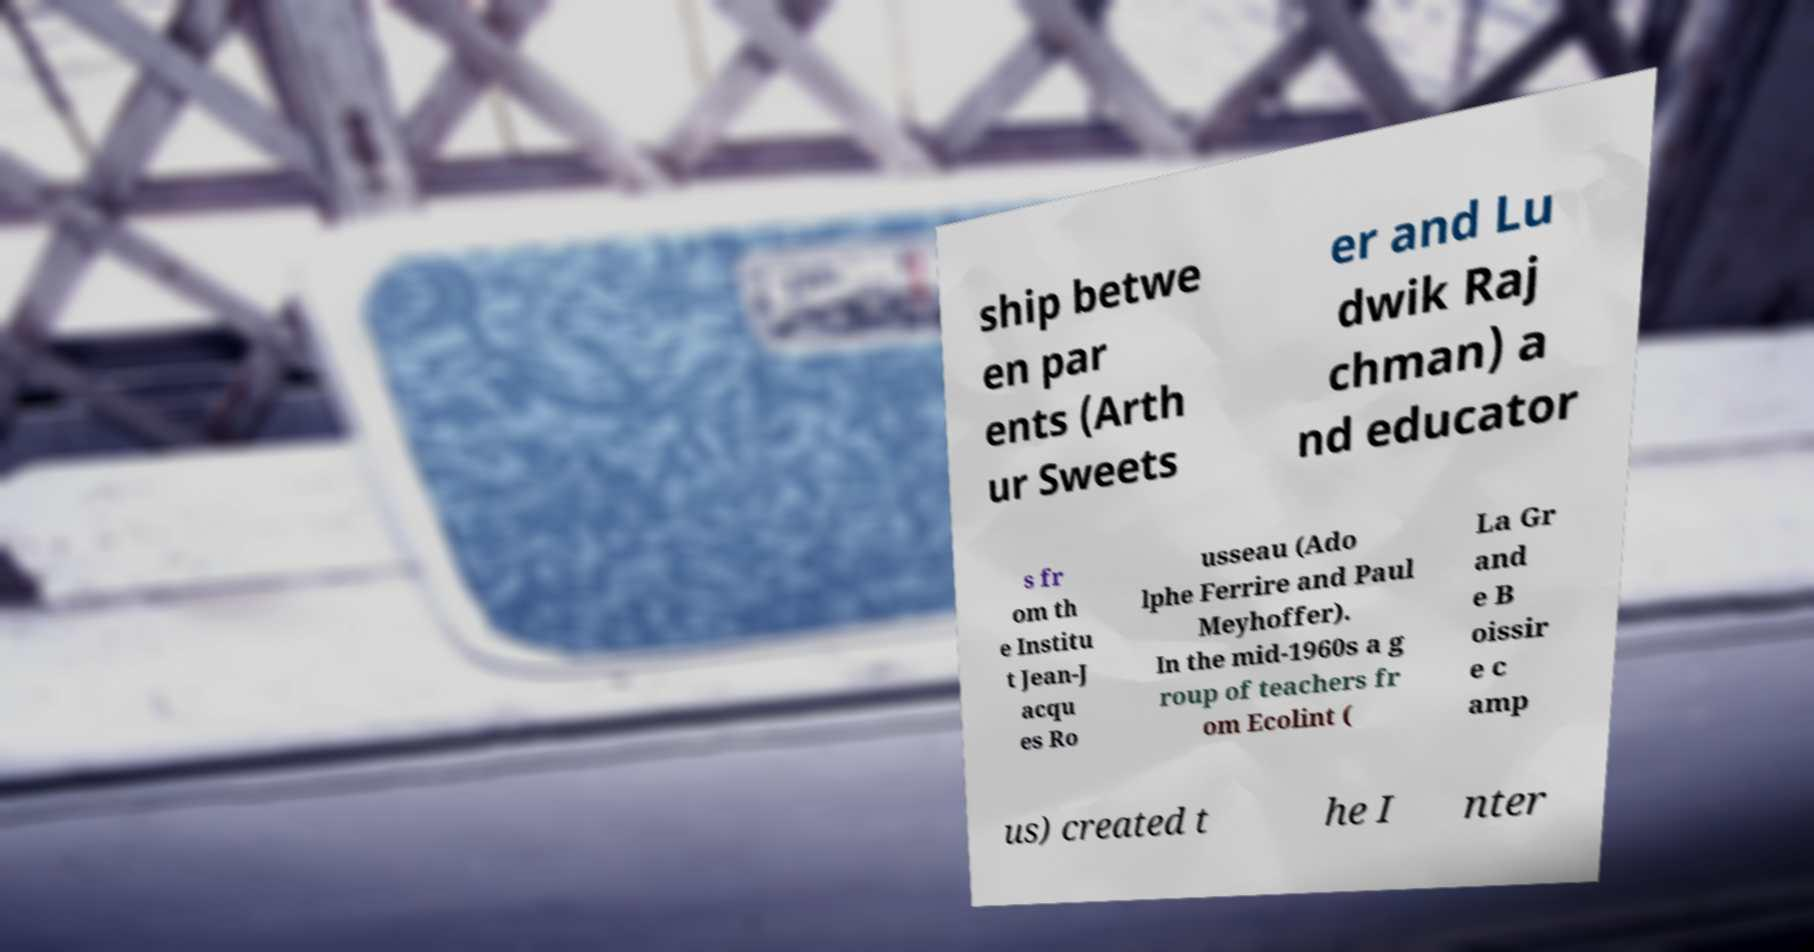Please read and relay the text visible in this image. What does it say? ship betwe en par ents (Arth ur Sweets er and Lu dwik Raj chman) a nd educator s fr om th e Institu t Jean-J acqu es Ro usseau (Ado lphe Ferrire and Paul Meyhoffer). In the mid-1960s a g roup of teachers fr om Ecolint ( La Gr and e B oissir e c amp us) created t he I nter 